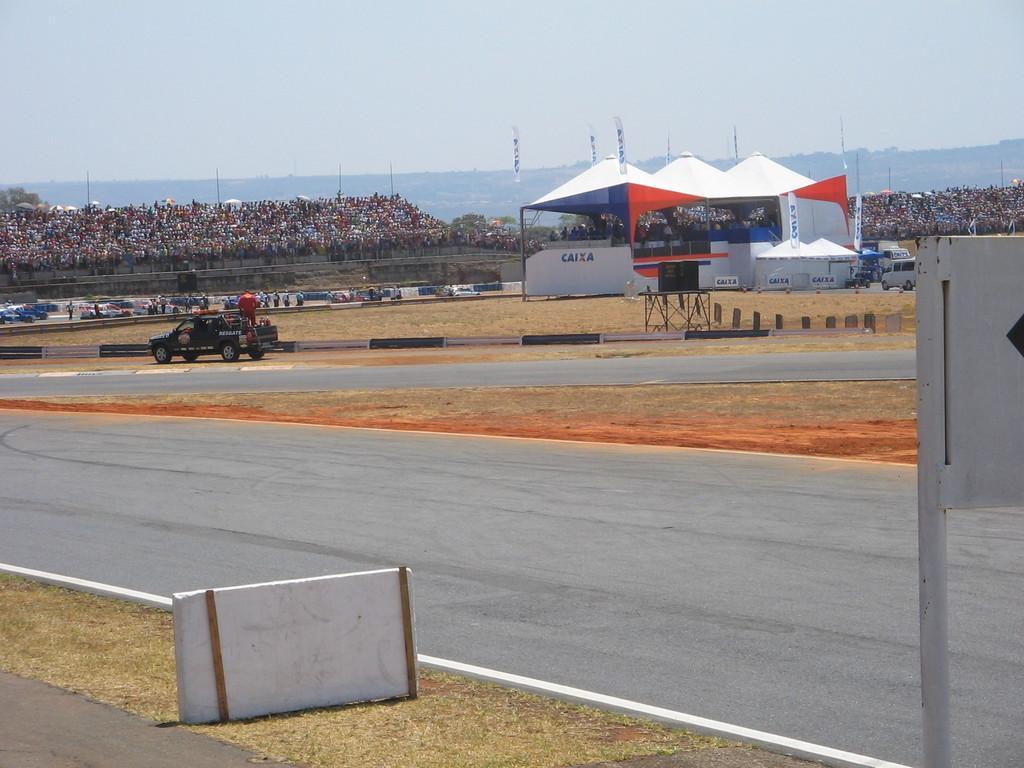In one or two sentences, can you explain what this image depicts? In this image I can see the vehicle on the road. In the background I can see the tent and the tent is in white and orange color and I can also see group of people and I can also see the water and the sky is in white and blue color. 